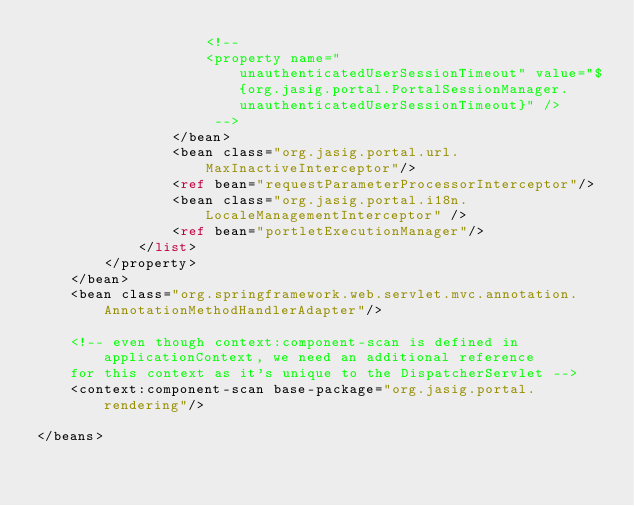<code> <loc_0><loc_0><loc_500><loc_500><_XML_>                    <!-- 
                    <property name="unauthenticatedUserSessionTimeout" value="${org.jasig.portal.PortalSessionManager.unauthenticatedUserSessionTimeout}" />
                     -->
                </bean>
                <bean class="org.jasig.portal.url.MaxInactiveInterceptor"/>
                <ref bean="requestParameterProcessorInterceptor"/>
                <bean class="org.jasig.portal.i18n.LocaleManagementInterceptor" />
                <ref bean="portletExecutionManager"/>
            </list>
        </property>
    </bean>
    <bean class="org.springframework.web.servlet.mvc.annotation.AnnotationMethodHandlerAdapter"/>
    
    <!-- even though context:component-scan is defined in applicationContext, we need an additional reference
    for this context as it's unique to the DispatcherServlet -->
    <context:component-scan base-package="org.jasig.portal.rendering"/>

</beans>
</code> 